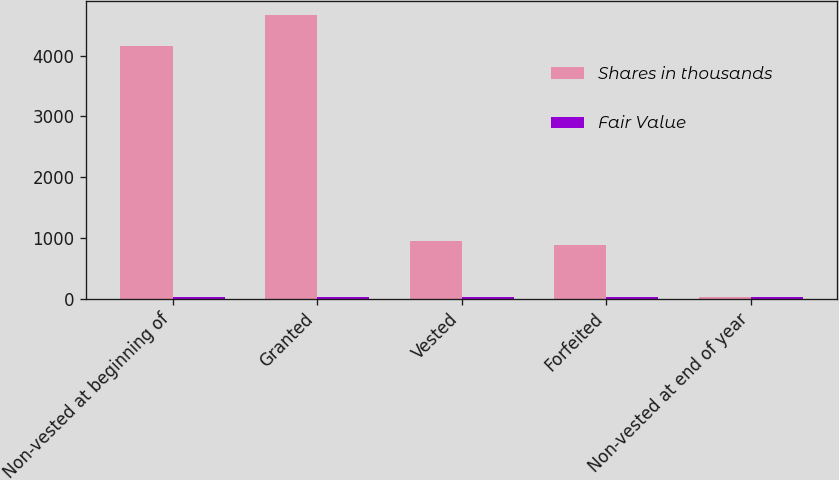Convert chart. <chart><loc_0><loc_0><loc_500><loc_500><stacked_bar_chart><ecel><fcel>Non-vested at beginning of<fcel>Granted<fcel>Vested<fcel>Forfeited<fcel>Non-vested at end of year<nl><fcel>Shares in thousands<fcel>4164<fcel>4667<fcel>956<fcel>884<fcel>30.13<nl><fcel>Fair Value<fcel>27.6<fcel>20.56<fcel>30.13<fcel>24.25<fcel>22.98<nl></chart> 